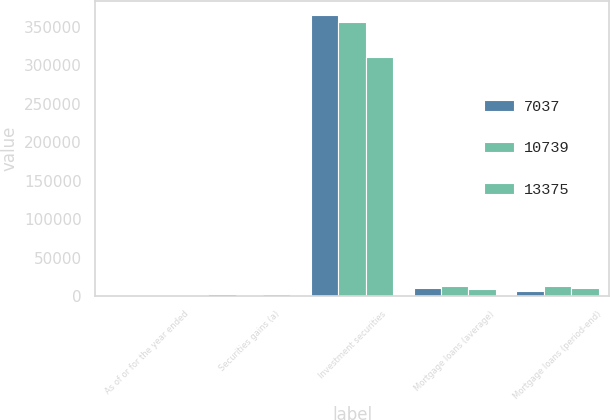Convert chart. <chart><loc_0><loc_0><loc_500><loc_500><stacked_bar_chart><ecel><fcel>As of or for the year ended<fcel>Securities gains (a)<fcel>Investment securities<fcel>Mortgage loans (average)<fcel>Mortgage loans (period-end)<nl><fcel>7037<fcel>2012<fcel>2028<fcel>365421<fcel>10241<fcel>7037<nl><fcel>10739<fcel>2011<fcel>1385<fcel>355605<fcel>13006<fcel>13375<nl><fcel>13375<fcel>2010<fcel>2897<fcel>310801<fcel>9004<fcel>10739<nl></chart> 